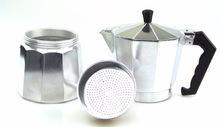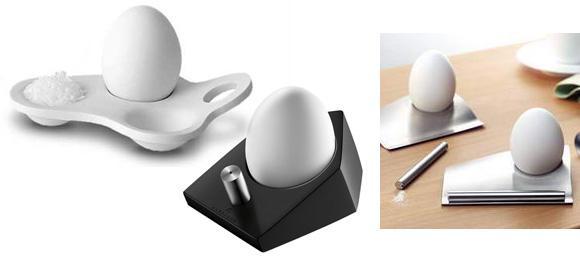The first image is the image on the left, the second image is the image on the right. Considering the images on both sides, is "There are three mugs in one of the images." valid? Answer yes or no. No. The first image is the image on the left, the second image is the image on the right. Analyze the images presented: Is the assertion "An image shows a row of three cups that are upside-down." valid? Answer yes or no. No. 